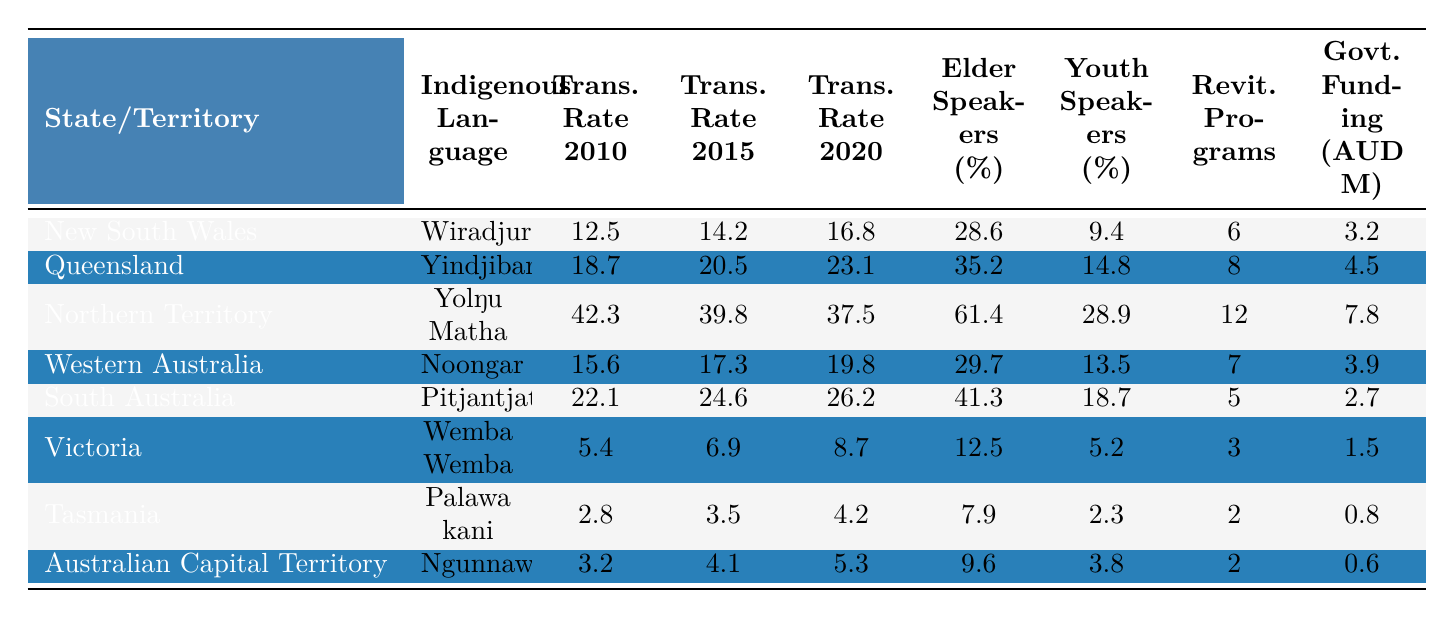What is the transmission rate of the Yolŋu Matha in 2020? The table shows that the transmission rate for Yolŋu Matha in 2020 is 37.5.
Answer: 37.5 Which state has the highest percentage of elder speakers of its indigenous language? By looking at the elder speakers percentages, Northern Territory has the highest value at 61.4.
Answer: Northern Territory What was the average transmission rate across all states in 2015? To find the average, sum the transmission rates in 2015 which are (14.2 + 20.5 + 39.8 + 17.3 + 24.6 + 6.9 + 4.1 + 4.1) = 131.5. There are 8 states, so the average is 131.5 / 8 = 16.44.
Answer: 16.44 Is the transmission rate of the Wemba Wemba language in 2020 higher than the youth speakers percentage? The transmission rate for Wemba Wemba in 2020 is 8.7, and the youth speakers percentage is 5.2. Since 8.7 is greater than 5.2, the statement is true.
Answer: Yes What was the percentage increase in the transmission rate of Yindjibarndi from 2010 to 2020? The transmission rate for Yindjibarndi in 2010 is 18.7 and in 2020 is 23.1. The increase is calculated as (23.1 - 18.7) = 4.4. The percentage increase is (4.4 / 18.7) * 100 ≈ 23.5%.
Answer: 23.5% Which language revitalization program received the least government funding, and how much was it? Looking at the government funding, Palawa kani had the least amount at 0.8 million.
Answer: Palawa kani, 0.8 million What was the overall trend in transmission rates for the Pitjantjatjara language from 2010 to 2020? The transmission rates for Pitjantjatjara are: 2010 = 22.1, 2015 = 24.6, and 2020 = 26.2, indicating a consistent increase over this period.
Answer: Increasing In which state do youth speakers represent a higher percentage compared to elder speakers? By comparing youth and elder speakers percentages, Queensland has 14.8 (youth) vs 35.2 (elder), which is not higher. Checking each state reveals that none have higher youth percentages than elder speakers.
Answer: None What is the total number of language revitalization programs across all states and territories? Summing the language revitalization programs: 6 + 8 + 12 + 7 + 5 + 3 + 2 + 2 = 45.
Answer: 45 Which state experienced the highest transmission rate increase from 2010 to 2020? By calculating the differences for each state: New South Wales (16.8 - 12.5 = 4.3), Queensland (23.1 - 18.7 = 4.4), Northern Territory (37.5 - 42.3 = -4.8), Western Australia (19.8 - 15.6 = 4.2), South Australia (26.2 - 22.1 = 4.1), Victoria (8.7 - 5.4 = 3.3), Tasmania (4.2 - 2.8 = 1.4), Australian Capital Territory (5.3 - 3.2 = 2.1). The highest increase is in Queensland at 4.4.
Answer: Queensland 